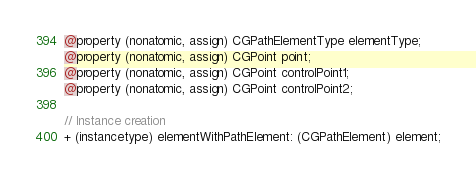Convert code to text. <code><loc_0><loc_0><loc_500><loc_500><_C_>@property (nonatomic, assign) CGPathElementType elementType;
@property (nonatomic, assign) CGPoint point;
@property (nonatomic, assign) CGPoint controlPoint1;
@property (nonatomic, assign) CGPoint controlPoint2;

// Instance creation
+ (instancetype) elementWithPathElement: (CGPathElement) element;</code> 